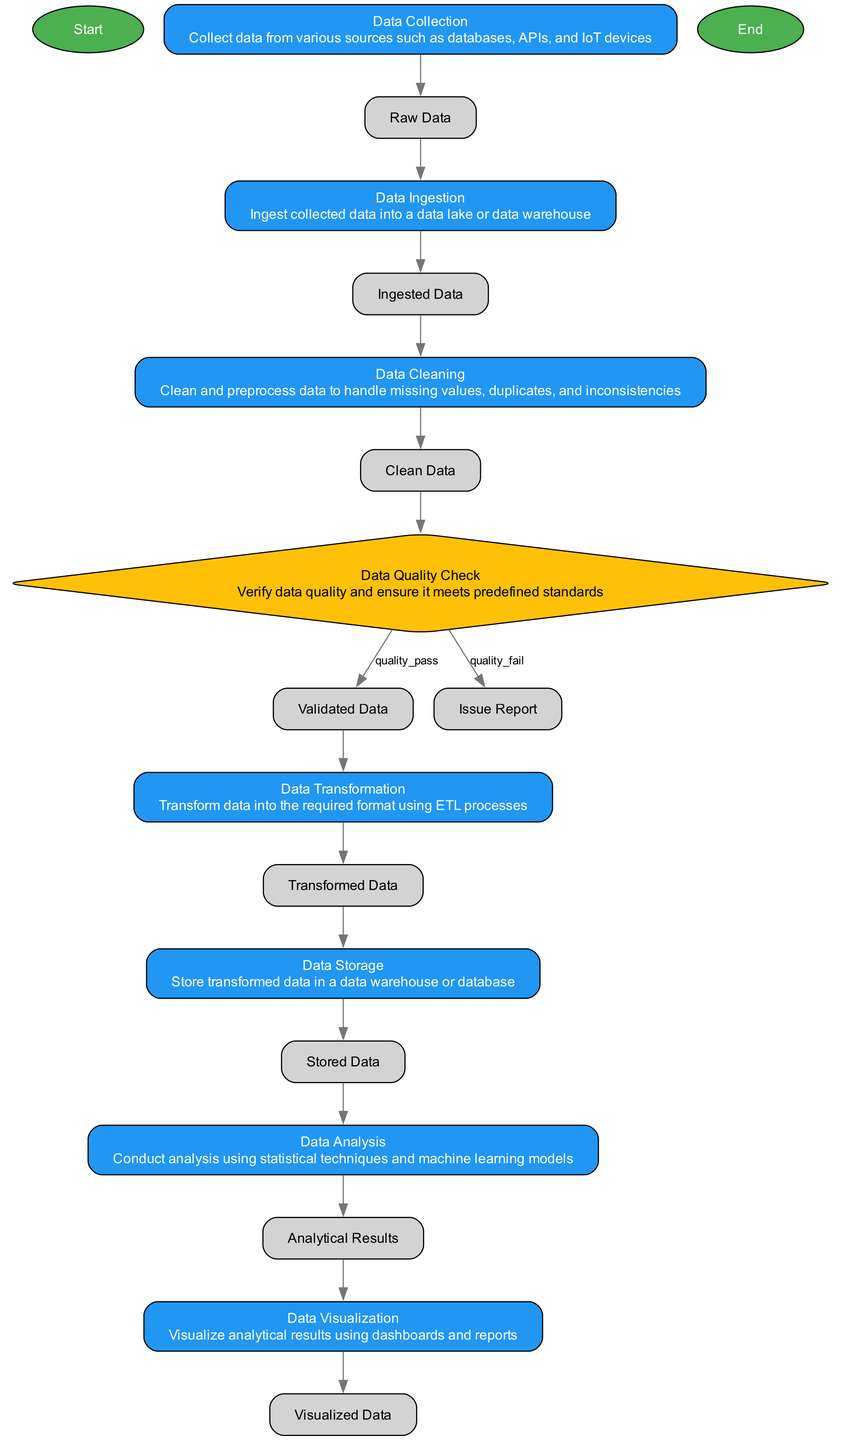What is the first action in the data pipeline process? The first action in the diagram is labeled as "Data Collection." It is the first node that follows the "Start" node, indicating that data collection occurs immediately after starting the process.
Answer: Data Collection How many actions are present in the diagram? By counting the nodes of type "action," we find that there are six actions: Data Collection, Data Ingestion, Data Cleaning, Data Transformation, Data Storage, and Data Analysis. Therefore, the total count of action nodes is six.
Answer: Six What happens if the data quality check fails? If the data quality check fails, the output is labeled as "Issue Report." This is clearly outlined in the decision node where the fail outcome points to the issue report, indicating that the process cannot proceed without addressing the quality issues.
Answer: Issue Report What is the output of the "Data Cleaning" action? The output of the "Data Cleaning" action is labeled as "Clean Data." This is specified in the action node for Data Cleaning and indicates the results of this process.
Answer: Clean Data What are the two outputs of the "Data Quality Check" decision? The two outputs of the "Data Quality Check" decision are "Validated Data" if the quality is passed and "Issue Report" if the quality fails. This is noted in the decision node, showing the paths based on the outcome of the check.
Answer: Validated Data, Issue Report What is the penultimate action before data visualization? The penultimate action before data visualization is "Data Analysis." It takes the input from the "Stored Data" node and produces the "Analytical Results," which are the direct input for the final visualization step.
Answer: Data Analysis Where does the "Stored Data" action receive input from? The "Stored Data" action receives input from the "Transformed Data" action. This is indicated in the diagram where the flow from "Transformed Data" leads directly into the "Stored Data" action.
Answer: Transformed Data What is the final output of the data pipeline process? The final output of the data pipeline process is labeled as "Visualized Data." This result comes from the "Data Visualization" action, which takes the analytical results as its input before concluding the process.
Answer: Visualized Data 